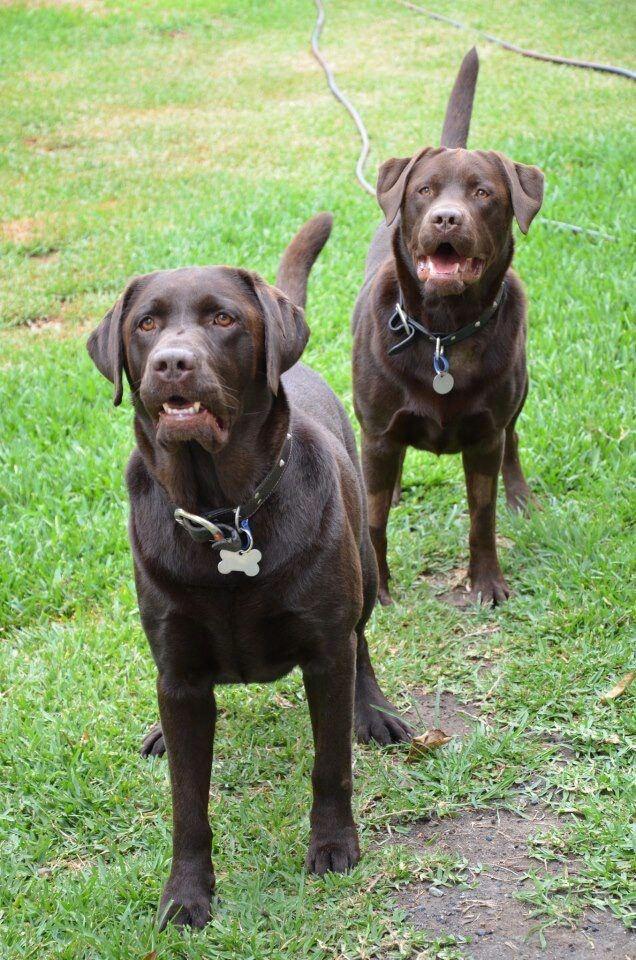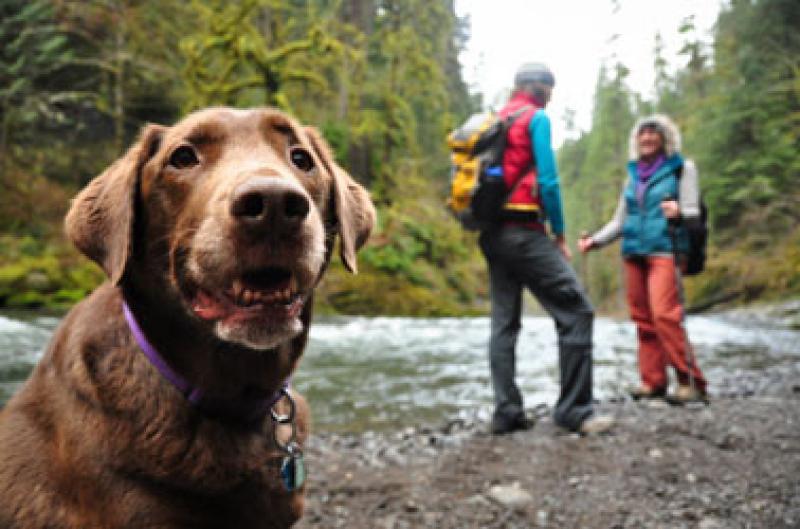The first image is the image on the left, the second image is the image on the right. Analyze the images presented: Is the assertion "The dog on the left is wearing a back pack" valid? Answer yes or no. No. The first image is the image on the left, the second image is the image on the right. Assess this claim about the two images: "There is at least one dog wearing a red pack.". Correct or not? Answer yes or no. No. 